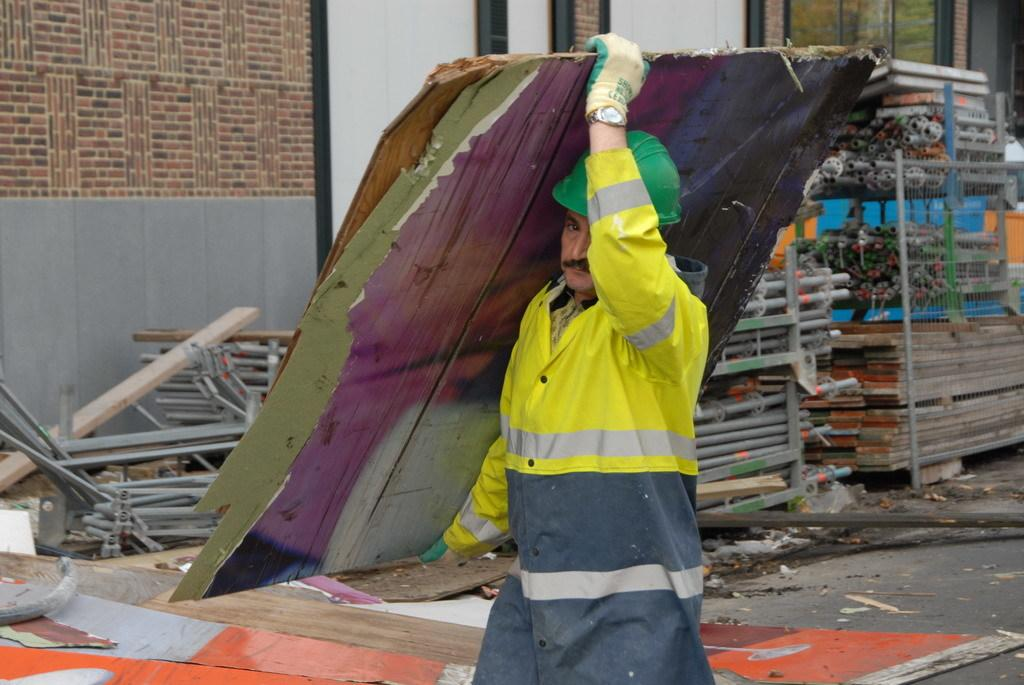What is the main subject of the image? There is a man in the image. What is the man holding in the image? The man is holding wooden planks. What can be seen in the background of the image? There are iron frames and wooden planks visible in the background. What architectural feature is present in the image? There is a window in the image. What type of wall is visible in the image? There is a brick wall in the image. What type of noise can be heard coming from the pets in the image? There are no pets present in the image, so no noise can be heard from them. 